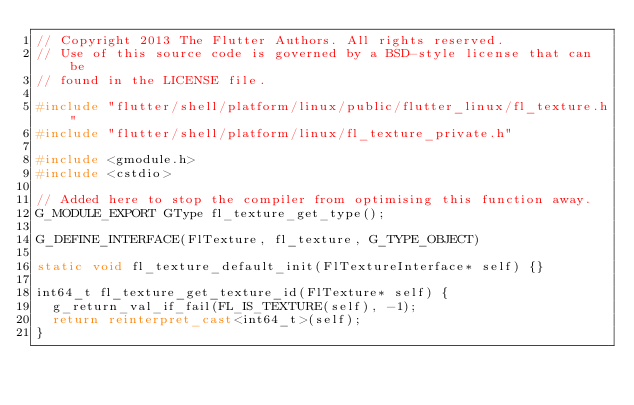<code> <loc_0><loc_0><loc_500><loc_500><_C++_>// Copyright 2013 The Flutter Authors. All rights reserved.
// Use of this source code is governed by a BSD-style license that can be
// found in the LICENSE file.

#include "flutter/shell/platform/linux/public/flutter_linux/fl_texture.h"
#include "flutter/shell/platform/linux/fl_texture_private.h"

#include <gmodule.h>
#include <cstdio>

// Added here to stop the compiler from optimising this function away.
G_MODULE_EXPORT GType fl_texture_get_type();

G_DEFINE_INTERFACE(FlTexture, fl_texture, G_TYPE_OBJECT)

static void fl_texture_default_init(FlTextureInterface* self) {}

int64_t fl_texture_get_texture_id(FlTexture* self) {
  g_return_val_if_fail(FL_IS_TEXTURE(self), -1);
  return reinterpret_cast<int64_t>(self);
}
</code> 